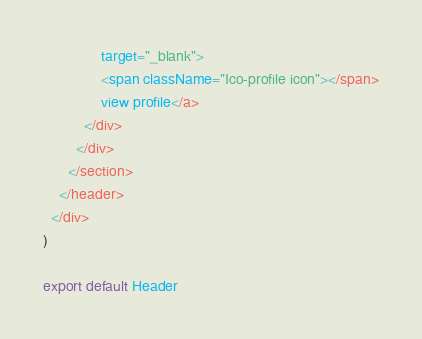<code> <loc_0><loc_0><loc_500><loc_500><_JavaScript_>              target="_blank">
              <span className="Ico-profile icon"></span>
              view profile</a>
          </div>
        </div>
      </section>
    </header>
  </div>
)

export default Header
</code> 